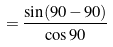Convert formula to latex. <formula><loc_0><loc_0><loc_500><loc_500>= \frac { \sin ( 9 0 - 9 0 ) } { \cos 9 0 }</formula> 